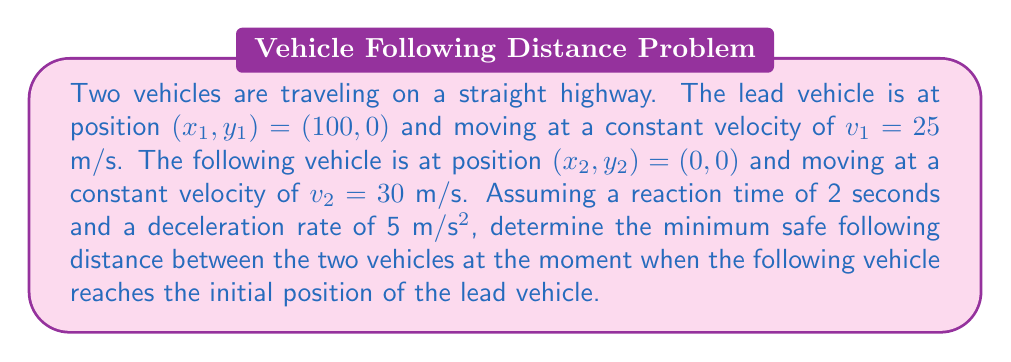Show me your answer to this math problem. To solve this problem, we need to consider the following steps:

1. Calculate the time it takes for the following vehicle to reach the lead vehicle's initial position:
   $$t = \frac{x_1 - x_2}{v_2} = \frac{100 - 0}{30} = 3.33 \text{ seconds}$$

2. Calculate the new position of the lead vehicle after 3.33 seconds:
   $$x_1' = x_1 + v_1 \cdot t = 100 + 25 \cdot 3.33 = 183.33 \text{ meters}$$

3. Calculate the safe following distance using the formula:
   $$d_{safe} = v_2 \cdot t_{reaction} + \frac{v_2^2 - v_1^2}{2a}$$
   
   Where:
   - $v_2$ is the velocity of the following vehicle (30 m/s)
   - $v_1$ is the velocity of the lead vehicle (25 m/s)
   - $t_{reaction}$ is the reaction time (2 seconds)
   - $a$ is the deceleration rate (5 m/s²)

4. Substitute the values into the formula:
   $$d_{safe} = 30 \cdot 2 + \frac{30^2 - 25^2}{2 \cdot 5}$$
   $$d_{safe} = 60 + \frac{900 - 625}{10}$$
   $$d_{safe} = 60 + 27.5 = 87.5 \text{ meters}$$

5. Calculate the actual distance between the vehicles:
   $$d_{actual} = x_1' - x_2' = 183.33 - 100 = 83.33 \text{ meters}$$

6. Compare the actual distance to the safe following distance:
   $$d_{actual} < d_{safe}$$
   $$83.33 \text{ m} < 87.5 \text{ m}$$

Therefore, the minimum safe following distance is 87.5 meters, which is 4.17 meters more than the actual distance between the vehicles at the specified moment.
Answer: The minimum safe following distance is 87.5 meters. 